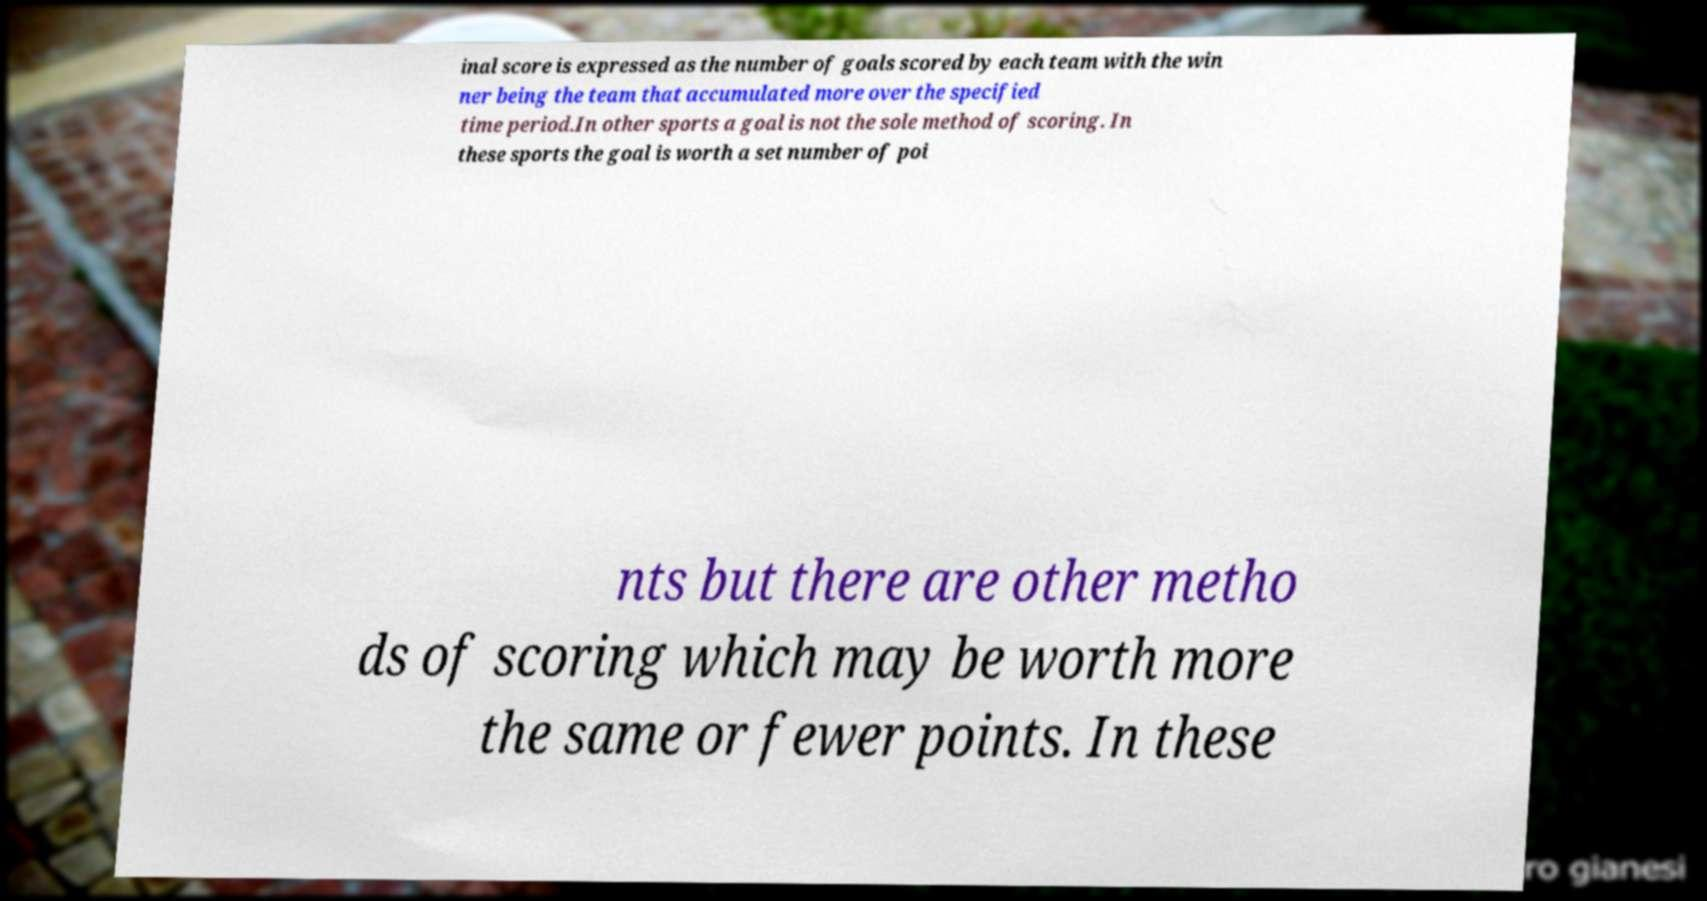Could you assist in decoding the text presented in this image and type it out clearly? inal score is expressed as the number of goals scored by each team with the win ner being the team that accumulated more over the specified time period.In other sports a goal is not the sole method of scoring. In these sports the goal is worth a set number of poi nts but there are other metho ds of scoring which may be worth more the same or fewer points. In these 